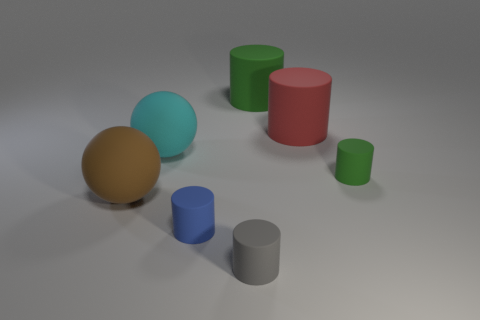Add 1 tiny metal things. How many objects exist? 8 Subtract all tiny gray matte cylinders. How many cylinders are left? 4 Subtract 1 spheres. How many spheres are left? 1 Subtract all brown balls. How many green cylinders are left? 2 Subtract 0 cyan cylinders. How many objects are left? 7 Subtract all spheres. How many objects are left? 5 Subtract all purple cylinders. Subtract all green blocks. How many cylinders are left? 5 Subtract all big cyan spheres. Subtract all tiny blue matte cylinders. How many objects are left? 5 Add 3 tiny blue things. How many tiny blue things are left? 4 Add 3 big red matte cylinders. How many big red matte cylinders exist? 4 